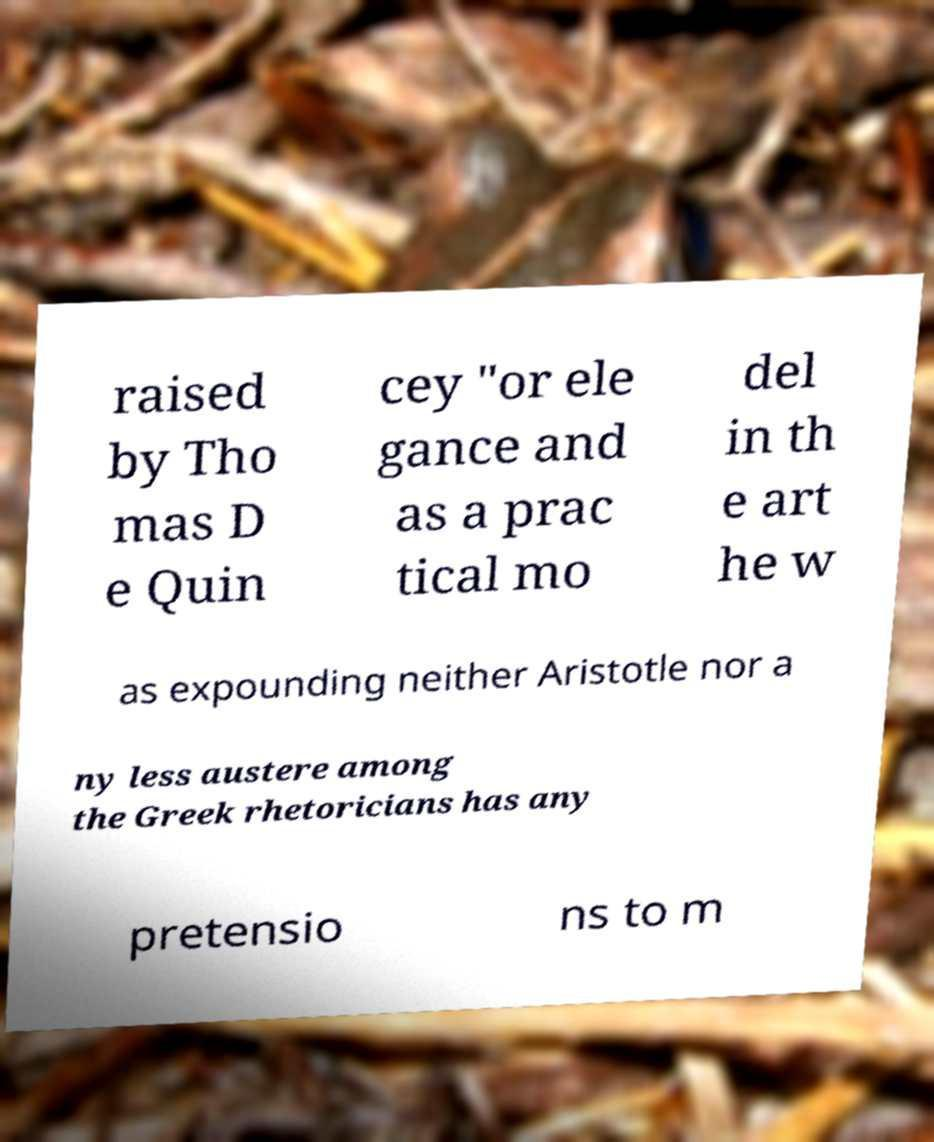I need the written content from this picture converted into text. Can you do that? raised by Tho mas D e Quin cey "or ele gance and as a prac tical mo del in th e art he w as expounding neither Aristotle nor a ny less austere among the Greek rhetoricians has any pretensio ns to m 